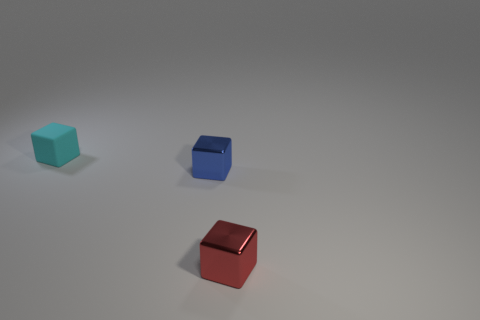There is a shiny object behind the tiny red shiny object; what shape is it?
Your response must be concise. Cube. Are there fewer small matte blocks that are on the left side of the small cyan thing than red cubes?
Your response must be concise. Yes. There is another thing that is made of the same material as the tiny red thing; what is its color?
Provide a short and direct response. Blue. How big is the object that is on the left side of the small blue metal cube?
Ensure brevity in your answer.  Small. Is the blue object made of the same material as the cyan cube?
Provide a succinct answer. No. Is there a thing that is to the left of the small thing in front of the shiny cube that is behind the red thing?
Provide a short and direct response. Yes. What is the color of the tiny rubber object?
Ensure brevity in your answer.  Cyan. What color is the other matte cube that is the same size as the red cube?
Ensure brevity in your answer.  Cyan. Do the shiny object that is behind the red object and the small cyan object have the same shape?
Ensure brevity in your answer.  Yes. There is a tiny cube left of the small metal cube behind the tiny red block in front of the blue cube; what is its color?
Ensure brevity in your answer.  Cyan. 